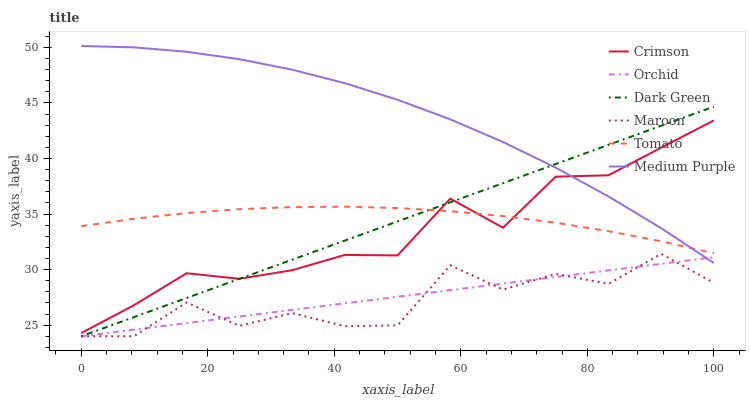Does Maroon have the minimum area under the curve?
Answer yes or no. Yes. Does Medium Purple have the maximum area under the curve?
Answer yes or no. Yes. Does Medium Purple have the minimum area under the curve?
Answer yes or no. No. Does Maroon have the maximum area under the curve?
Answer yes or no. No. Is Dark Green the smoothest?
Answer yes or no. Yes. Is Maroon the roughest?
Answer yes or no. Yes. Is Medium Purple the smoothest?
Answer yes or no. No. Is Medium Purple the roughest?
Answer yes or no. No. Does Maroon have the lowest value?
Answer yes or no. Yes. Does Medium Purple have the lowest value?
Answer yes or no. No. Does Medium Purple have the highest value?
Answer yes or no. Yes. Does Maroon have the highest value?
Answer yes or no. No. Is Orchid less than Tomato?
Answer yes or no. Yes. Is Medium Purple greater than Maroon?
Answer yes or no. Yes. Does Crimson intersect Dark Green?
Answer yes or no. Yes. Is Crimson less than Dark Green?
Answer yes or no. No. Is Crimson greater than Dark Green?
Answer yes or no. No. Does Orchid intersect Tomato?
Answer yes or no. No. 